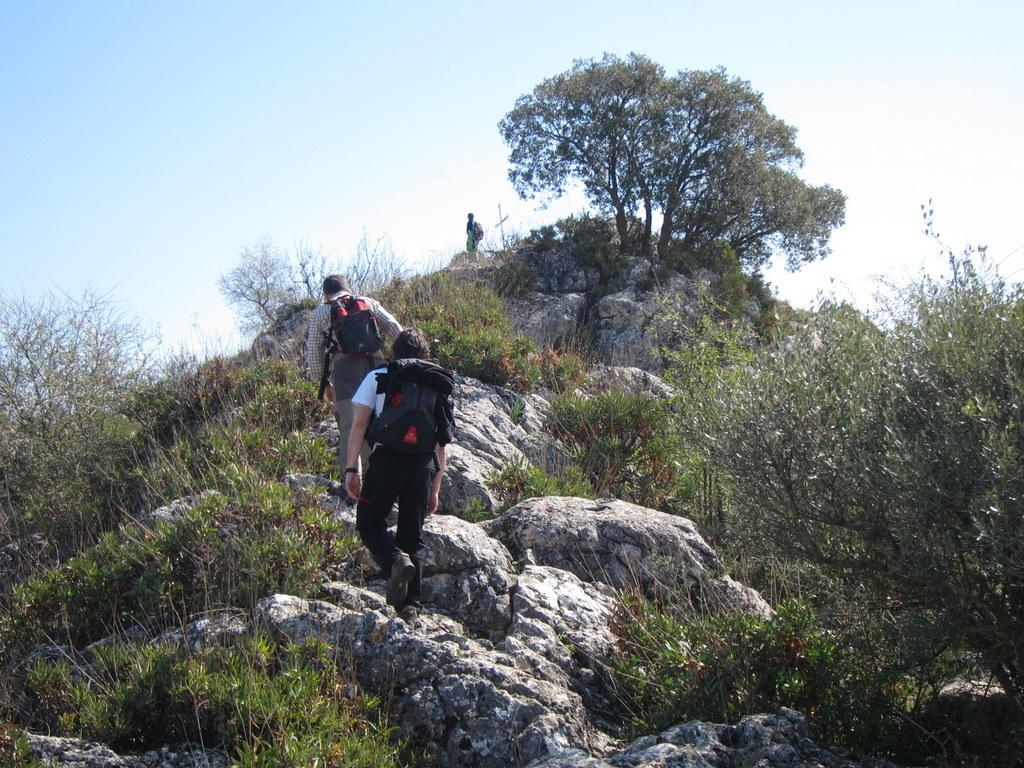What are the people in the image doing? The people in the image are climbing a mountain. Can you describe the background of the image? A: There is a person standing in the backdrop, along with rocks, plants, and trees. What type of terrain can be seen in the image? The terrain includes rocks, plants, and trees. What type of jelly can be seen on the rocks in the image? There is no jelly present in the image; it features people climbing a mountain with rocks, plants, and trees in the background. 